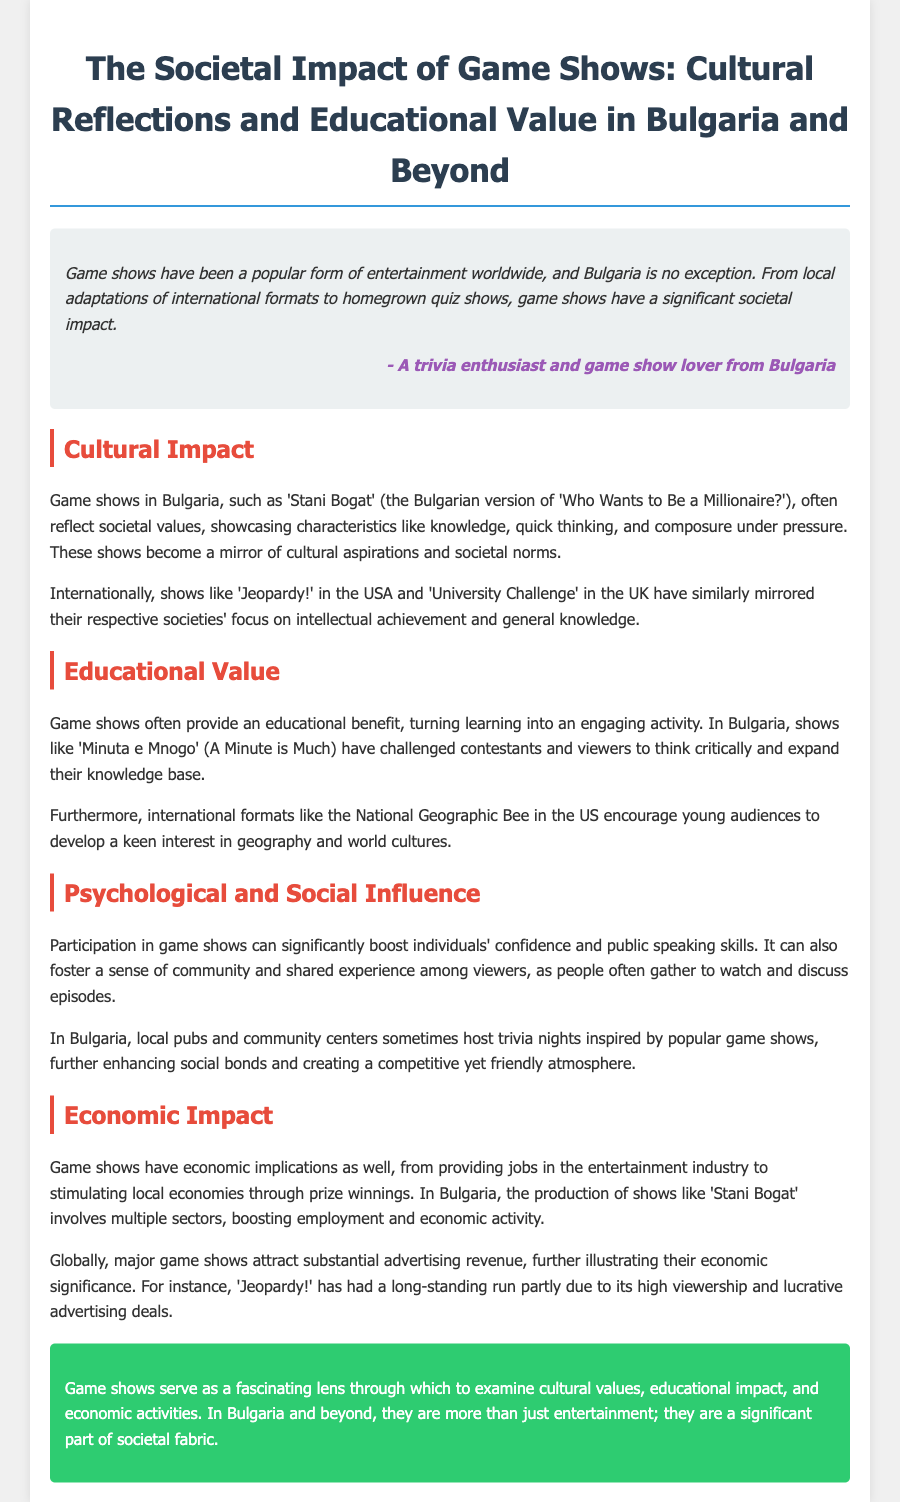What is the title of the case study? The title of the case study is presented prominently at the top of the document.
Answer: The Societal Impact of Game Shows: Cultural Reflections and Educational Value in Bulgaria and Beyond What is the name of the Bulgarian game show that reflects societal values? The document mentions a specific Bulgarian game show that showcases characteristics such as knowledge and quick thinking.
Answer: Stani Bogat Which international game show is mentioned as mirroring societal focus on intellectual achievement? The document references a popular game show from the USA that reflects societal aspirations.
Answer: Jeopardy! What type of educational benefit do game shows provide? The case study highlights the engaging nature of game shows and the critical thinking they encourage among viewers.
Answer: Critical thinking What effect can participation in game shows have on individuals? The document states a potential psychological benefit of participating in game shows, specifically related to personal development.
Answer: Confidence What local event inspired by game shows is mentioned in Bulgaria? The text includes a community activity that replicates the format of game shows and fosters social interaction.
Answer: Trivia nights What economic impact do game shows have in Bulgaria? The case study discusses how game shows contribute to the entertainment industry and create job opportunities.
Answer: Job creation Which game show has significant advertising revenue mentioned in the document? The document refers to a specific long-running game show known for its viewership and advertisement deals.
Answer: Jeopardy! 